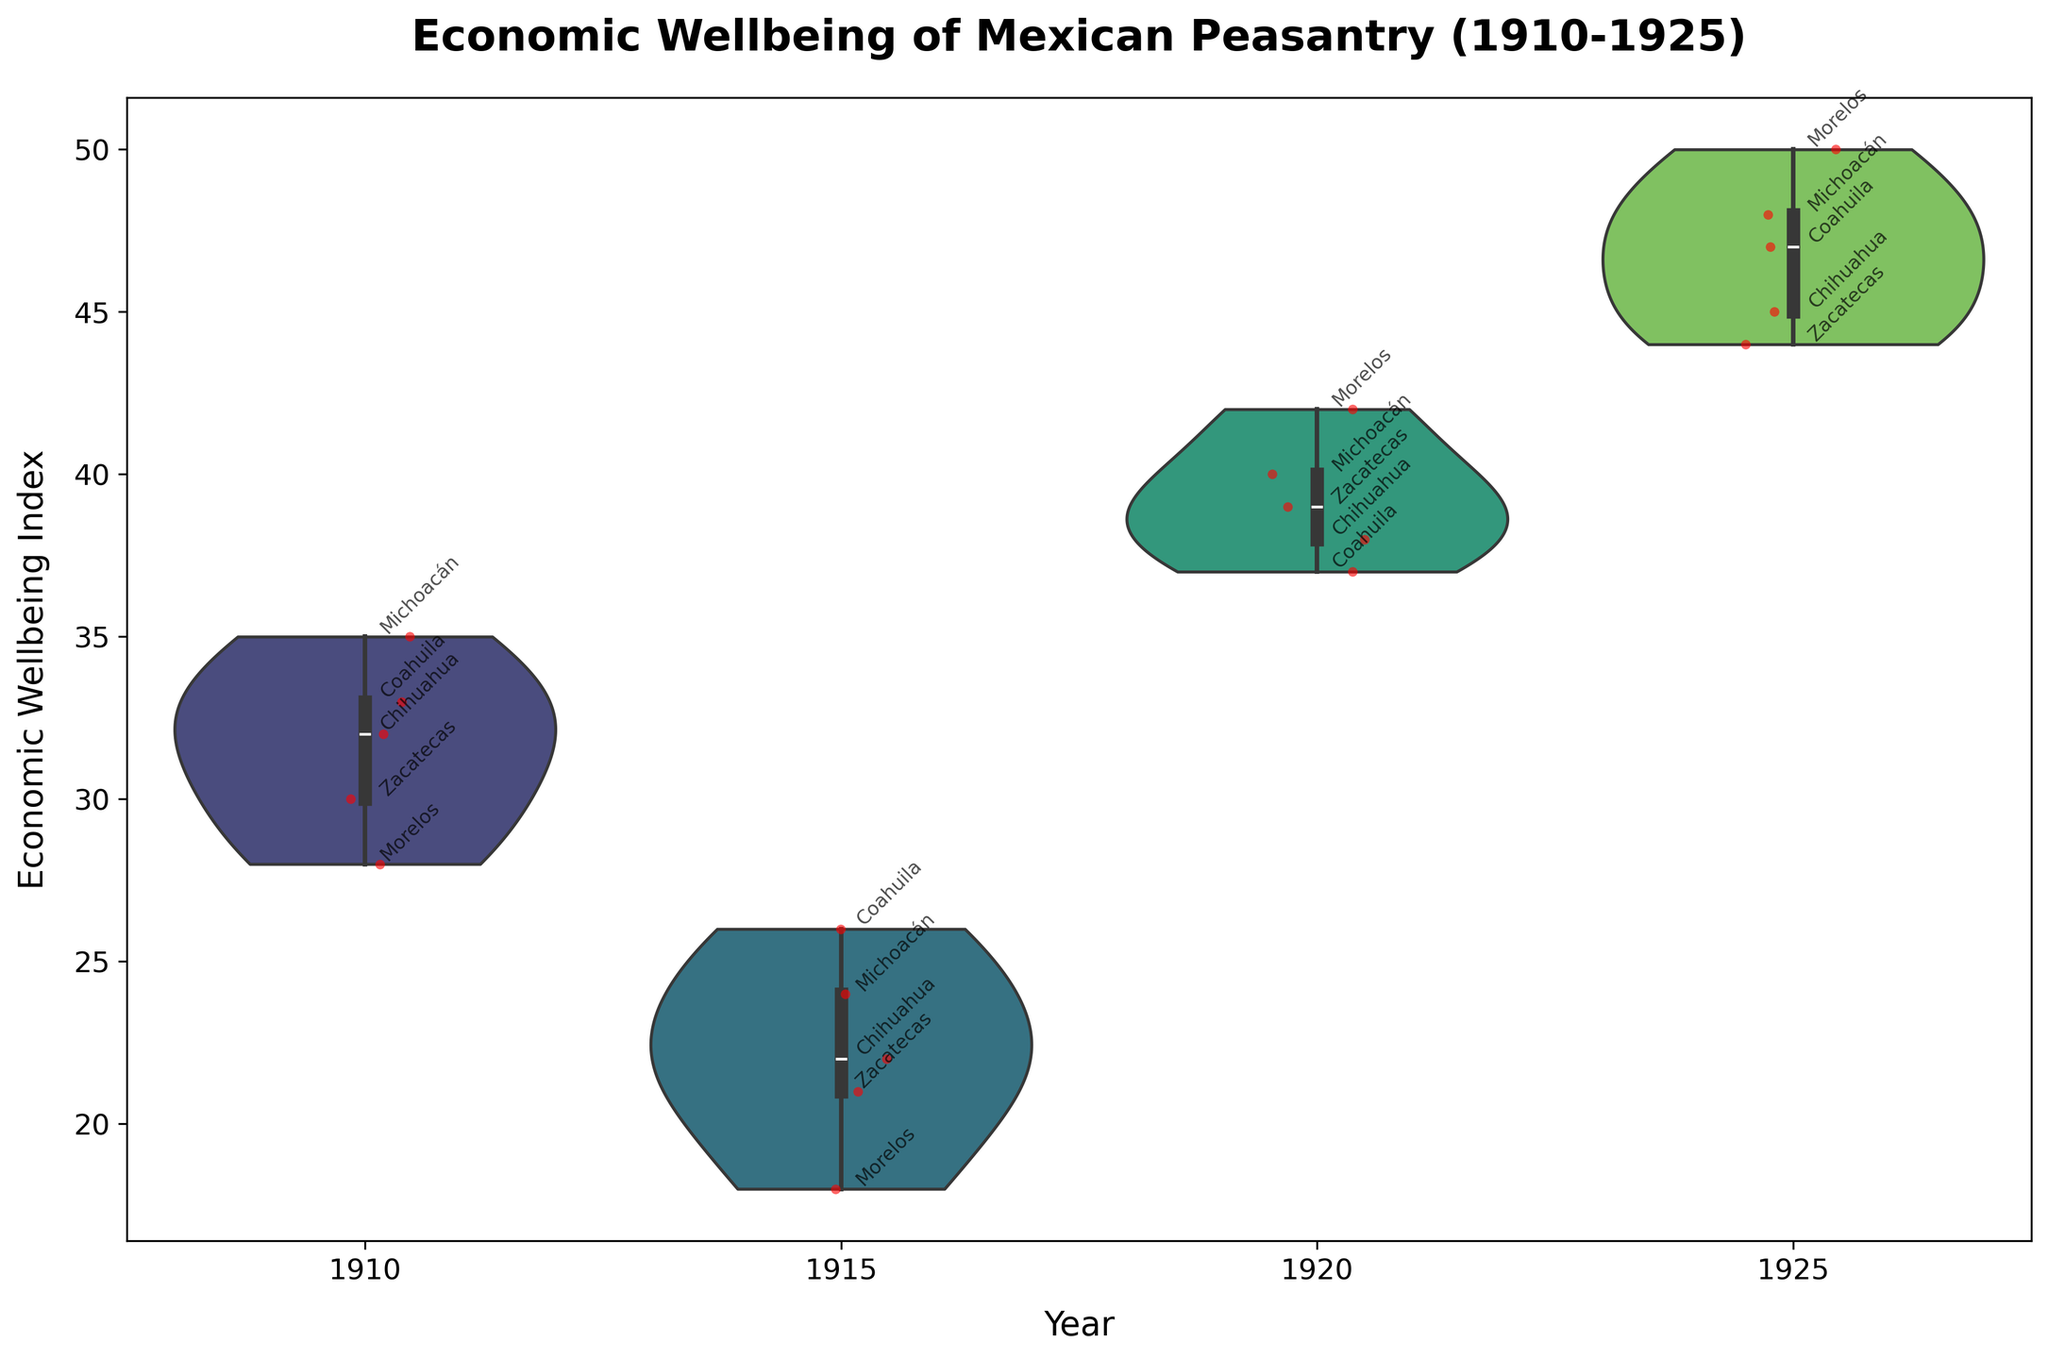What is the title of the plot? The title is located at the top of the plot and provides a concise summary of what the plot represents. Here, it's "Economic Wellbeing of Mexican Peasantry (1910-1925)."
Answer: Economic Wellbeing of Mexican Peasantry (1910-1925) Which year has the highest median economic wellbeing index? The median can be observed from the center line of the box plot that is overlaid on the violin plot. The plot shows the highest median occurs in 1925.
Answer: 1925 Which region had the lowest economic wellbeing index in 1915? To identify this, look at the red dots for the year 1915. The lowest point labelled is for Morelos with an index of 18.
Answer: Morelos How has the distribution of economic wellbeing changed from 1910 to 1920? The distribution can be seen through the shape of the violins and the box plots. In 1910, the distribution is more uniform, whereas in 1920 it becomes more skewed with higher values. The variance increases over this period.
Answer: Skewed with higher values, wider variance Were there any years with outliers in economic wellbeing index? Outliers would be seen as dots outside the whiskers of the box plots. Just looking for such points, no obvious outliers are visible in the specified years.
Answer: No Compare the economic wellbeing of Chihuahua in 1915 and 1925. For this comparison, look at the red dots for Chihuahua in the years 1915 and 1925. The values are 22 in 1915 and 45 in 1925, showing a marked improvement.
Answer: Improved from 22 to 45 What can you say about the economic wellbeing of Morelos over the years? Observing the points for Morelos, it starts at 28 in 1910, drops to 18 in 1915, rises sharply to 42 in 1920, and then peaks at 50 in 1925. This trend shows significant fluctuation with final improvement.
Answer: Improvement after fluctuation Comparing the years 1910 and 1925, which year has the greater variance in economic wellbeing index? Variance can be inferred from the spread of the violin plots. The plot for 1925 is wider implying greater variance compared to the more compact plot for 1910.
Answer: 1925 What is the trend in economic wellbeing index from 1915 to 1925? The trend can be observed by looking at the medians and distributions from each year's violin plot. Starting at low values in 1915, it gradually increases steadily through to 1925.
Answer: Increasing trend 